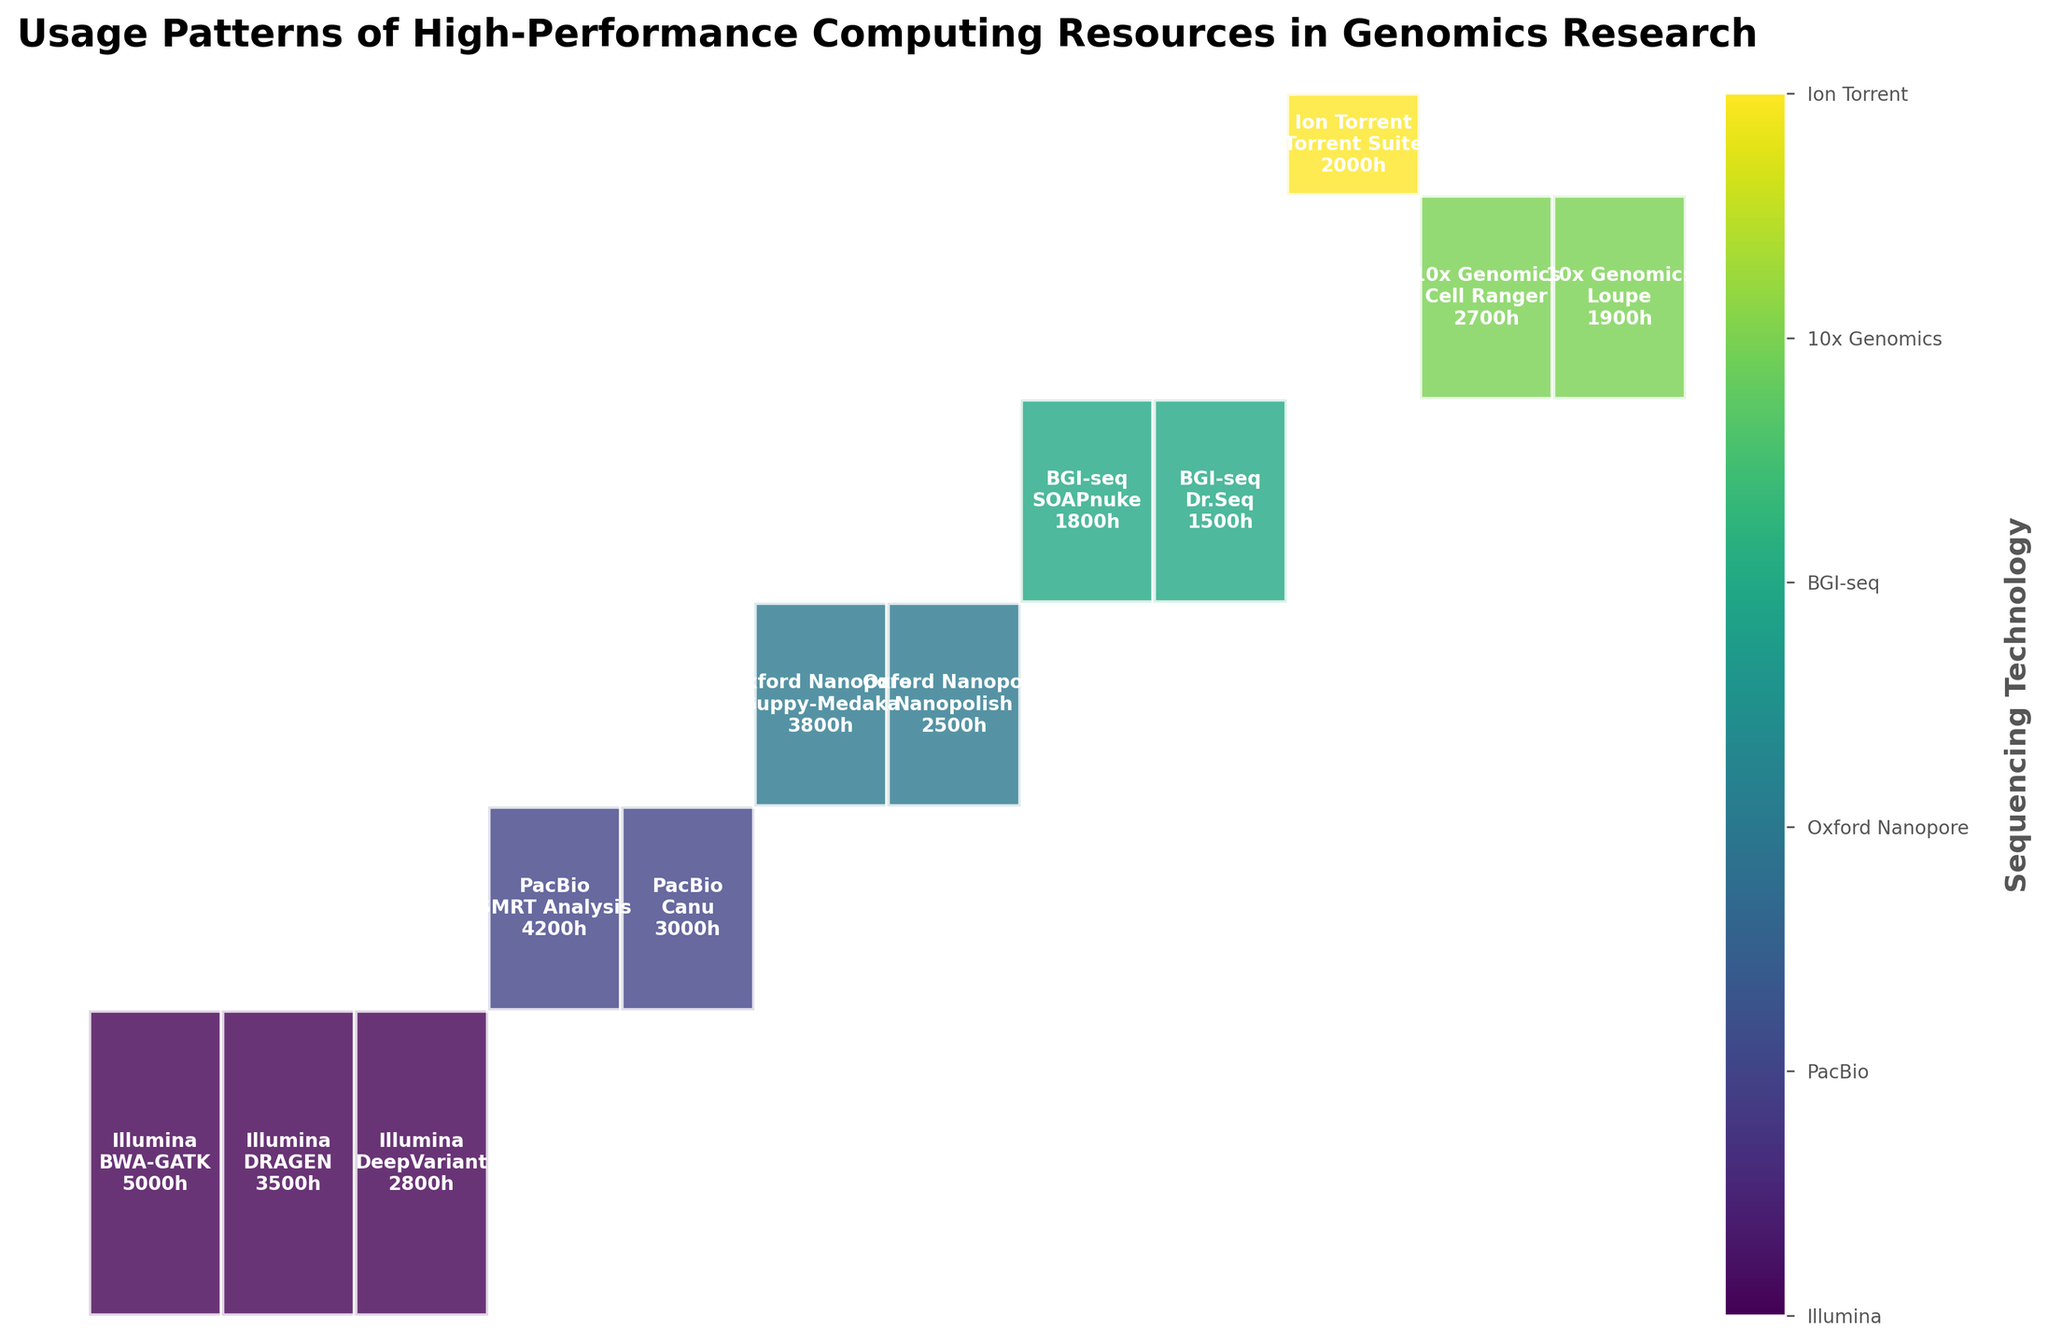What is the most used sequencing technology in terms of total usage hours? To determine the most used sequencing technology, sum the usage hours for each technology. Illumina has the highest sum with 11,300 hours (5000 + 3500 + 2800).
Answer: Illumina Which analysis pipeline showed the highest usage hours for PacBio sequencing technology? For PacBio technology, compare the usage hours of SMRT Analysis and Canu. SMRT Analysis has 4200 hours, which is higher than Canu's 3000 hours.
Answer: SMRT Analysis How many different sequencing technologies are represented in the plot? Count the distinct categories within the Sequencing Technology axis. The technologies shown are Illumina, PacBio, Oxford Nanopore, BGI-seq, Ion Torrent, and 10x Genomics.
Answer: 6 Which sequencing technology and analysis pipeline combination used exactly 1500 hours? Identify the combinations and their corresponding usage hours from the plot. The combination BGI-seq with Dr.Seq is the only one with 1500 hours.
Answer: BGI-seq, Dr.Seq Between the usage hours of Guppy-Medaka and Nanopolish for Oxford Nanopore, which one is greater? Compare 3800 hours for Guppy-Medaka and 2500 hours for Nanopolish. 3800 is greater than 2500.
Answer: Guppy-Medaka Which analysis pipeline has the highest sum of usage hours across all sequencing technologies? Sum the usage hours of each pipeline across all technologies. BWA-GATK (5000), DRAGEN (3500), DeepVariant (2800), SMRT Analysis (4200), Canu (3000), Guppy-Medaka (3800), Nanopolish (2500), SOAPnuke (1800), Dr.Seq (1500), Torrent Suite (2000), Cell Ranger (2700), Loupe (1900). The pipeline SMRT Analysis has the highest sum with 4200 hours.
Answer: SMRT Analysis Are there any analysis pipelines used by more than one sequencing technology? Identify if any pipeline names repeat for different technologies in the plot. All pipelines are unique to their respective technologies.
Answer: No What percentage of total usage hours does Illumina with DRAGEN contribute? Calculate the percentage by dividing the usage hours of Illumina with DRAGEN (3500) by the total usage hours (33200), then multiply by 100. 3500 / 33200 * 100 ≈ 10.54%.
Answer: 10.54% Is there any sequencing technology with only one associated analysis pipeline? Identify if any of the represented technologies are linked to just one pipeline. Ion Torrent (Torrent Suite) and BGI-seq (SOAPnuke) each have only one pipeline.
Answer: Yes, Ion Torrent and BGI-seq Which combination has the smallest usage hours? From the data, the combination with the smallest usage hours is BGI-seq with Dr.Seq, which has 1500 hours.
Answer: BGI-seq, Dr.Seq 